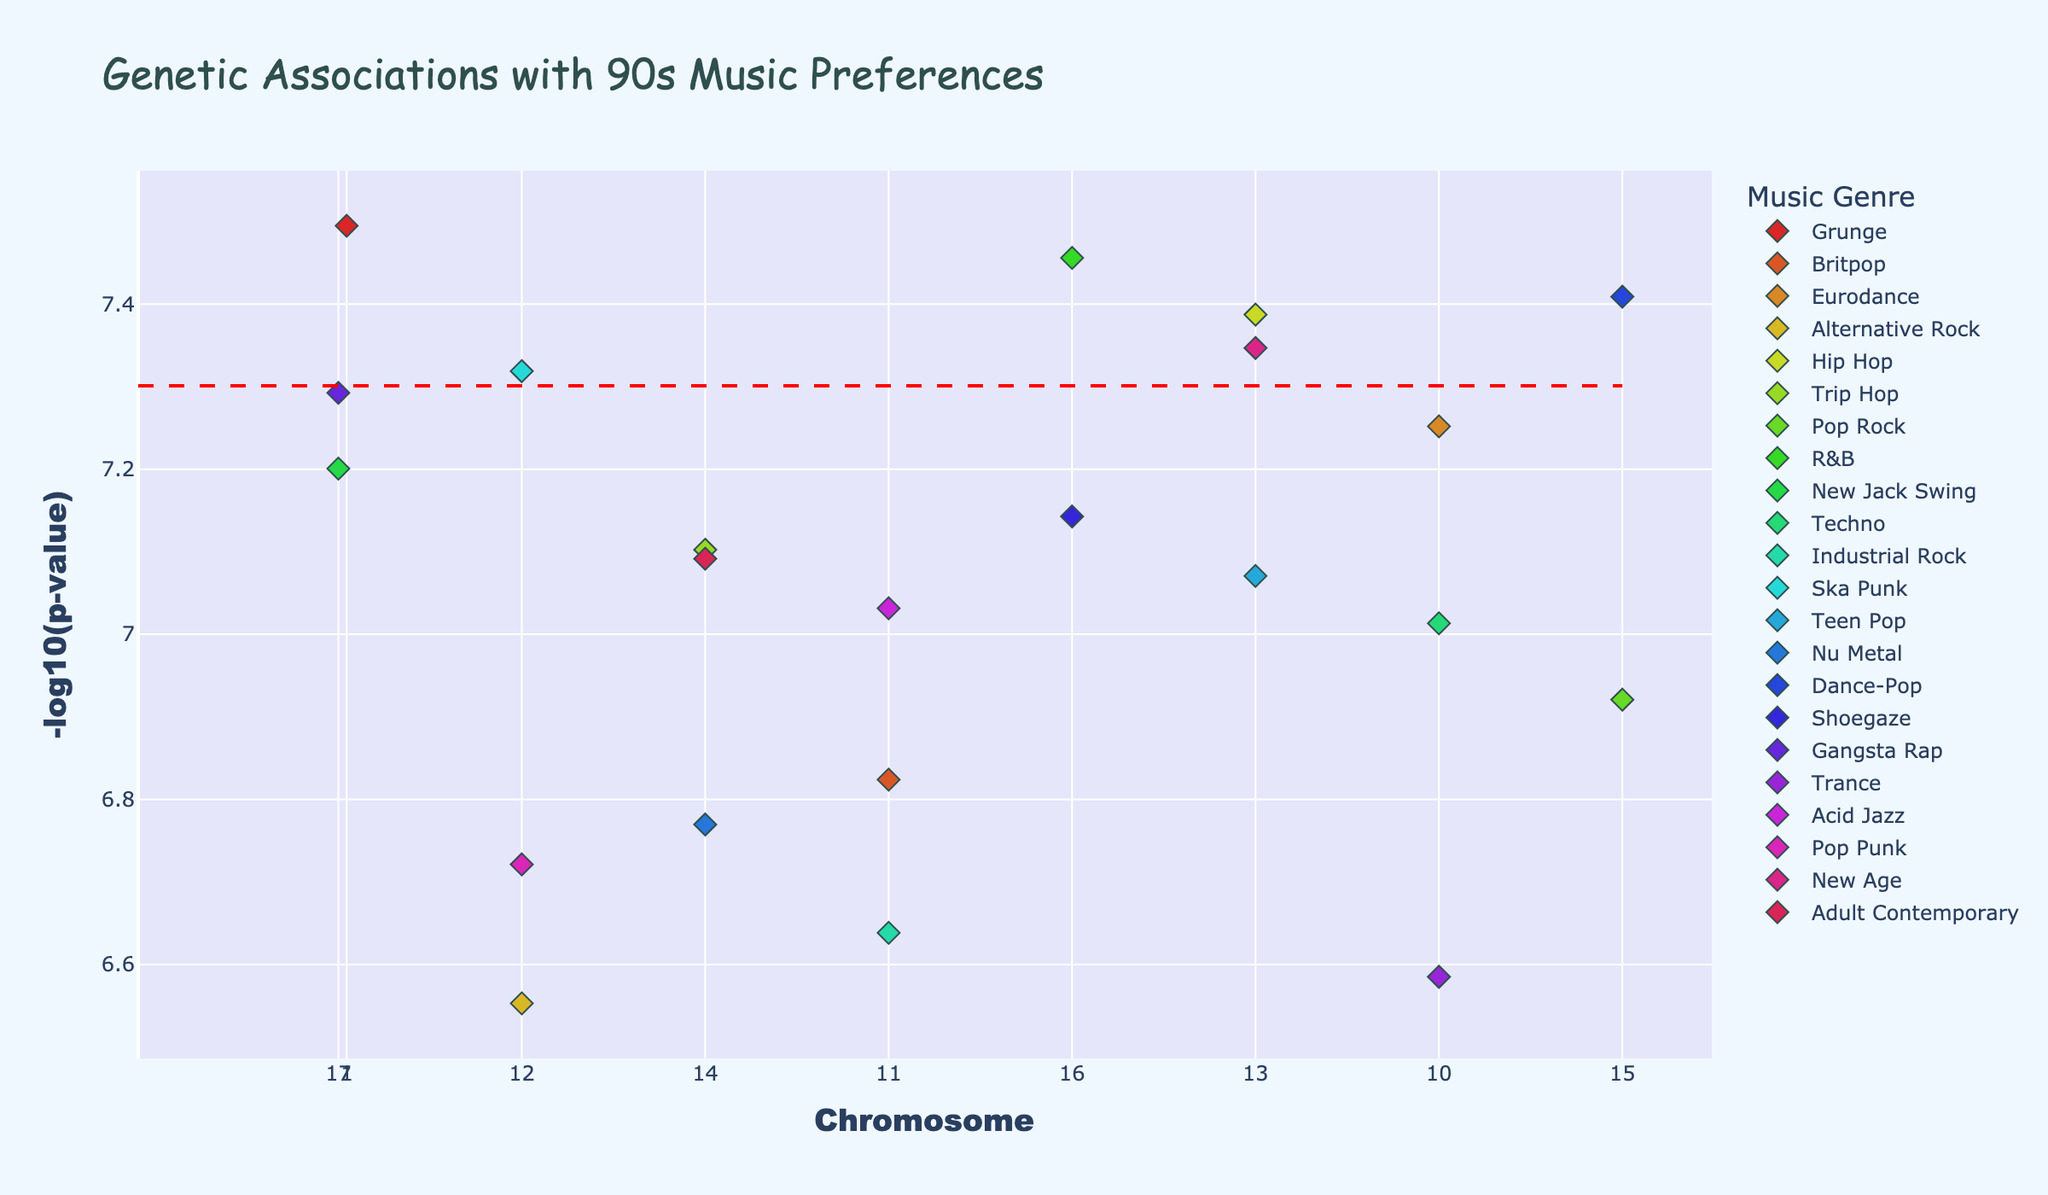What is the title of the plot? The title of the plot is at the top of the figure. It reads, "Genetic Associations with 90s Music Preferences".
Answer: Genetic Associations with 90s Music Preferences Which genre has the highest -log10(p-value) and what is its value? By looking at the highest point on the y-axis, "Grunge" has the highest -log10(p-value) and the peak value is around 7.5.
Answer: Grunge, 7.5 How many genres are represented in the plot? Each genre has a unique color and the legend on the right shows all the genres. By counting the colors in the legend, we find there are 22 genres.
Answer: 22 Which gene is associated with Grunge music, and on which chromosome is it located? By hovering over the point associated with Grunge, we see that the gene FOXP2 is linked to Grunge, and it is located on chromosome 1.
Answer: FOXP2, chromosome 1 What is the significance threshold shown in the plot? The significance threshold is represented by a horizontal dashed red line. By looking at the y-axis value where the line is drawn, it corresponds to -log10(5e-8).
Answer: -log10(5e-8) What is the chromosome position for the Hip Hop associated gene? By hovering over the data point related to Hip Hop, we see that the gene COMT represents Hip Hop, and its chromosome position value is 67000000.
Answer: 67000000 Which genre has the gene on the highest chromosome number and what is the -log10(p-value) of this gene? The highest chromosome number is 22. Hovering over the related point shows that "Adult Contemporary" is the genre, and its -log10(p-value) is approximately 7.1.
Answer: Adult Contemporary, 7.1 What is the difference in -log10(p-value) between the highest value and the threshold? The highest -log10(p-value) is approximately 7.5 for Grunge. The threshold is -log10(5e-8), which is 7.3. The difference is 7.5 - 7.3.
Answer: 0.2 Which genres are associated with genes on chromosome 8 and what are their -log10(p-values)? By inspecting the points on chromosome 8, "R&B" is associated with gene OXTR at around -log10(p-value) of 7.4.
Answer: R&B, 7.4 How does the -log10(p-value) for the gene associated with Pop Rock compare to that associated with Techno? By hovering over the respective points, "Pop Rock" associated gene OPRM1 has a -log10(p-value) of about 6.9, while "Techno" associated gene MAOA has a -log10(p-value) of approximately 7.
Answer: MAOA > OPRM1 